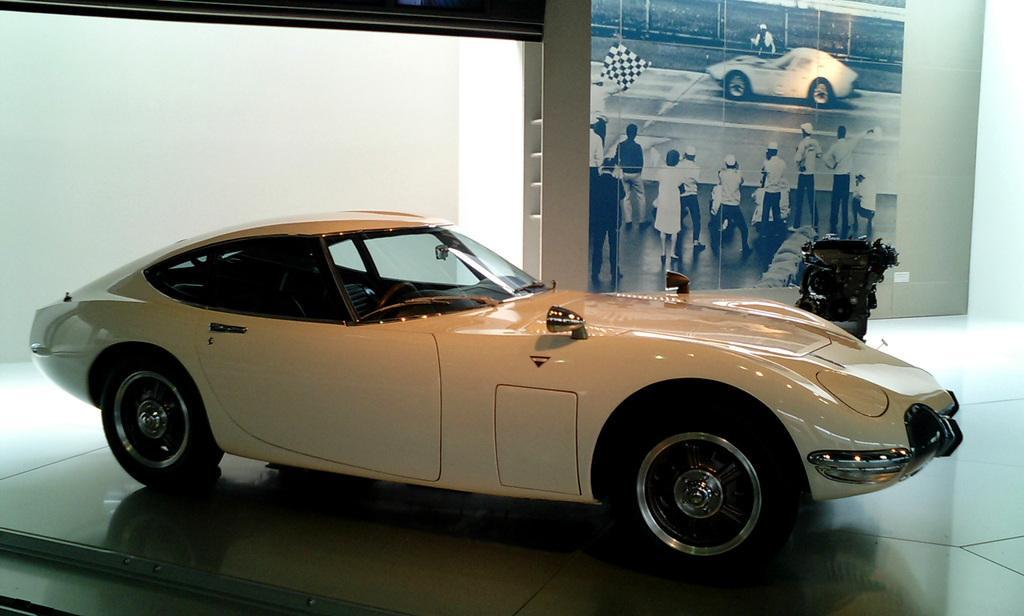How would you summarize this image in a sentence or two? In this image I can see a white color cars on the floor. On the board I can see few people,vehicle and one person is holding a flag. The board is attached to the white wall. 